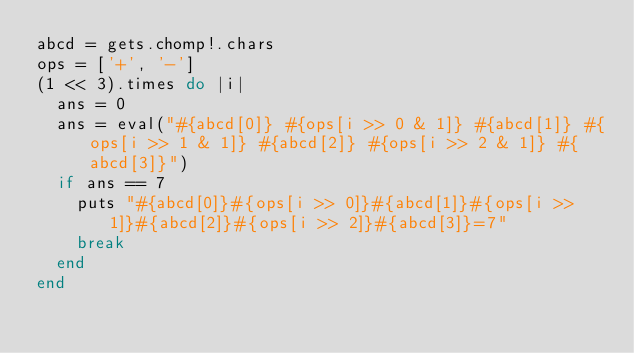Convert code to text. <code><loc_0><loc_0><loc_500><loc_500><_Ruby_>abcd = gets.chomp!.chars
ops = ['+', '-']
(1 << 3).times do |i|
  ans = 0
  ans = eval("#{abcd[0]} #{ops[i >> 0 & 1]} #{abcd[1]} #{ops[i >> 1 & 1]} #{abcd[2]} #{ops[i >> 2 & 1]} #{abcd[3]}")
  if ans == 7
    puts "#{abcd[0]}#{ops[i >> 0]}#{abcd[1]}#{ops[i >> 1]}#{abcd[2]}#{ops[i >> 2]}#{abcd[3]}=7"
    break
  end
end
</code> 